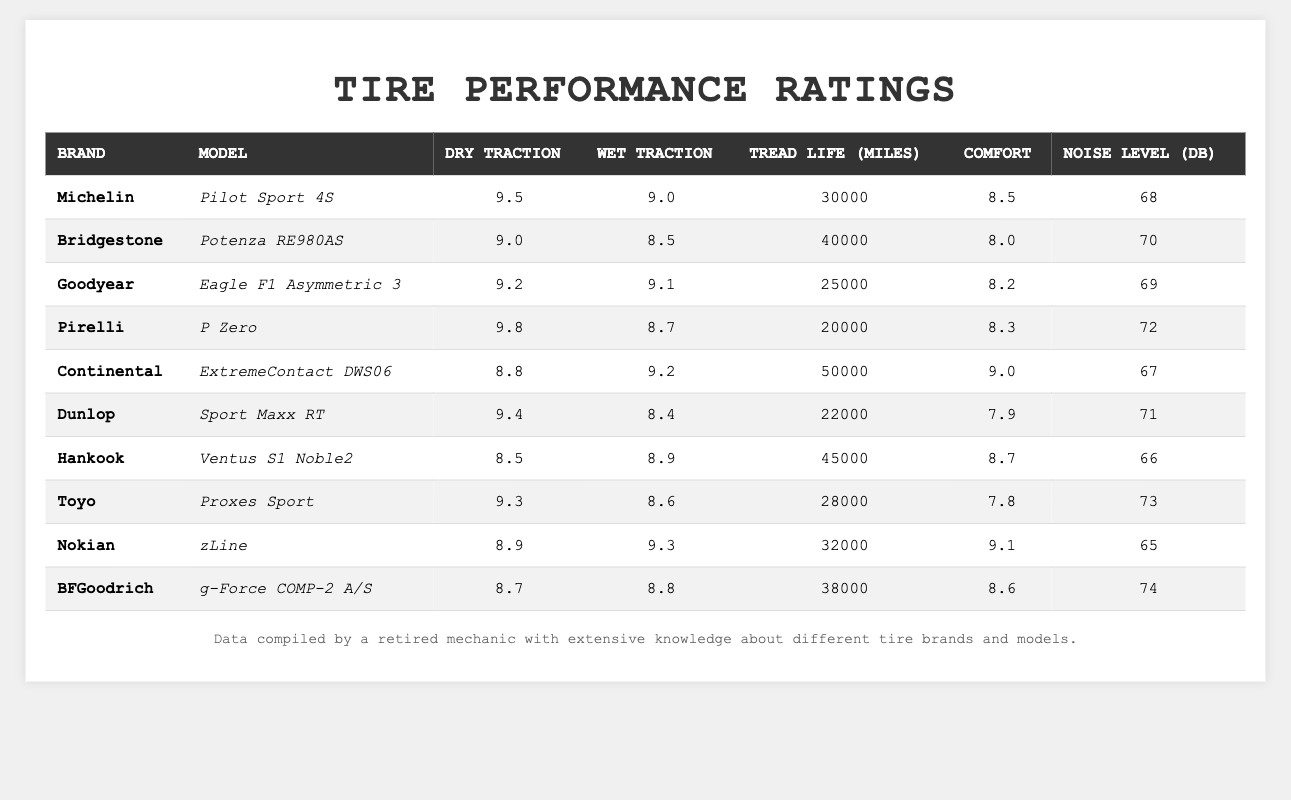What is the highest dry traction rating among the tires? The highest dry traction rating is found by comparing the "Dry Traction" column. The maximum value is 9.8, which belongs to the Pirelli P Zero tire.
Answer: 9.8 Which tire has the longest tread life? By reviewing the "Tread Life (miles)" column, the tire with the longest tread life is the Continental ExtremeContact DWS06, which has a tread life of 50,000 miles.
Answer: 50,000 miles Is the noise level of the Michelin Pilot Sport 4S higher than 70 dB? The noise level of the Michelin Pilot Sport 4S is listed as 68 dB, which is lower than 70 dB. Therefore, the statement is false.
Answer: No What is the average wet traction rating of all tires listed? To find the average wet traction rating, add all the wet traction values and divide by the number of tires. The total is (9.0 + 8.5 + 9.1 + 8.7 + 9.2 + 8.4 + 8.9 + 8.6 + 9.3 + 8.8) = 88.5, so 88.5/10 = 8.85.
Answer: 8.85 Which tire models have a comfort rating of 9 or higher? Check the "Comfort" column for ratings of 9 or more. The only tire with a rating of 9 or higher is the Continental ExtremeContact DWS06 with a comfort rating of 9.0.
Answer: Continental ExtremeContact DWS06 What is the difference in dry traction between the highest and lowest rated tires? The highest-rated dry traction is 9.8 (Pirelli P Zero) and the lowest is 8.5 (Hankook Ventus S1 Noble2). The difference is 9.8 - 8.5 = 1.3.
Answer: 1.3 Do more tires have a wet traction rating greater than 9.0 or less than 9.0? By examining the "Wet Traction" ratings, we have 5 tires rated above 9.0 (Michelin, Goodyear, Continental, Nokian) and 5 tires rated below 9.0 (Bridgestone, Pirelli, Dunlop, Hankook, Toyo, BFGoodrich). Therefore, they are equal.
Answer: Equal Which tire has the highest comfort rating, and what is that rating? Reviewing the "Comfort" column, the highest comfort rating is 9.0, associated with the Continental ExtremeContact DWS06 tire.
Answer: 9.0 Is there a tire that offers both the lowest noise level and the highest tread life? The lowest noise level is 65 dB (Nokian zLine) and the highest tread life is 50,000 miles (Continental ExtremeContact DWS06). No single tire has both features, so it is false.
Answer: No What is the total dry traction rating for the top three tires? The top three tires based on dry traction are Pirelli (9.8), Michelin (9.5), and Dunlop (9.4). Adding these gives 9.8 + 9.5 + 9.4 = 28.7.
Answer: 28.7 